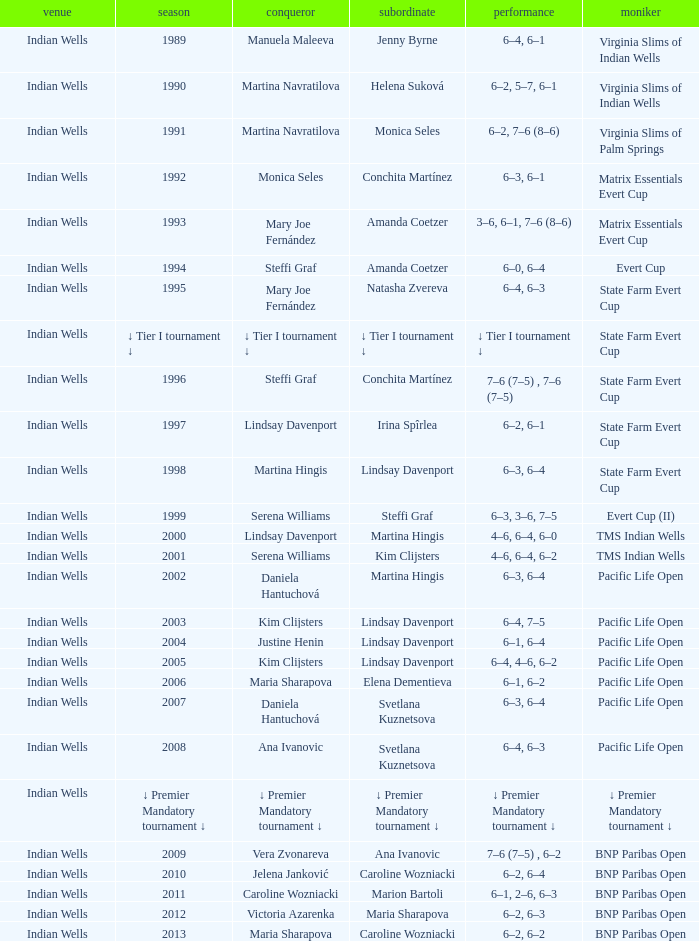Who was runner-up in the 2006 Pacific Life Open? Elena Dementieva. 